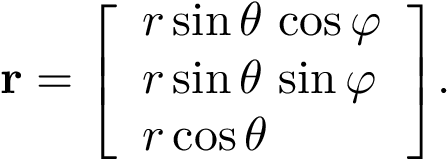Convert formula to latex. <formula><loc_0><loc_0><loc_500><loc_500>r = { \left [ \begin{array} { l } { r \sin \theta \, \cos \varphi } \\ { r \sin \theta \, \sin \varphi } \\ { r \cos \theta } \end{array} \right ] } .</formula> 